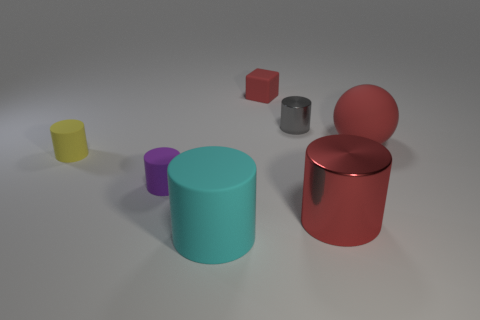There is a big ball that is the same color as the tiny block; what is it made of?
Provide a succinct answer. Rubber. The large cylinder that is the same material as the big ball is what color?
Give a very brief answer. Cyan. Are there an equal number of purple rubber objects that are right of the gray object and matte cylinders?
Your response must be concise. No. What is the shape of the purple rubber object that is the same size as the yellow object?
Ensure brevity in your answer.  Cylinder. What number of other things are there of the same shape as the small yellow rubber thing?
Your answer should be compact. 4. There is a gray object; is its size the same as the purple thing in front of the large sphere?
Keep it short and to the point. Yes. What number of objects are either objects that are in front of the small metal cylinder or big matte things?
Your response must be concise. 5. What is the shape of the big red thing behind the small purple rubber cylinder?
Offer a very short reply. Sphere. Are there an equal number of large cylinders in front of the cyan cylinder and gray objects that are left of the tiny yellow matte cylinder?
Your response must be concise. Yes. There is a thing that is both on the right side of the cube and to the left of the big red shiny object; what is its color?
Provide a succinct answer. Gray. 